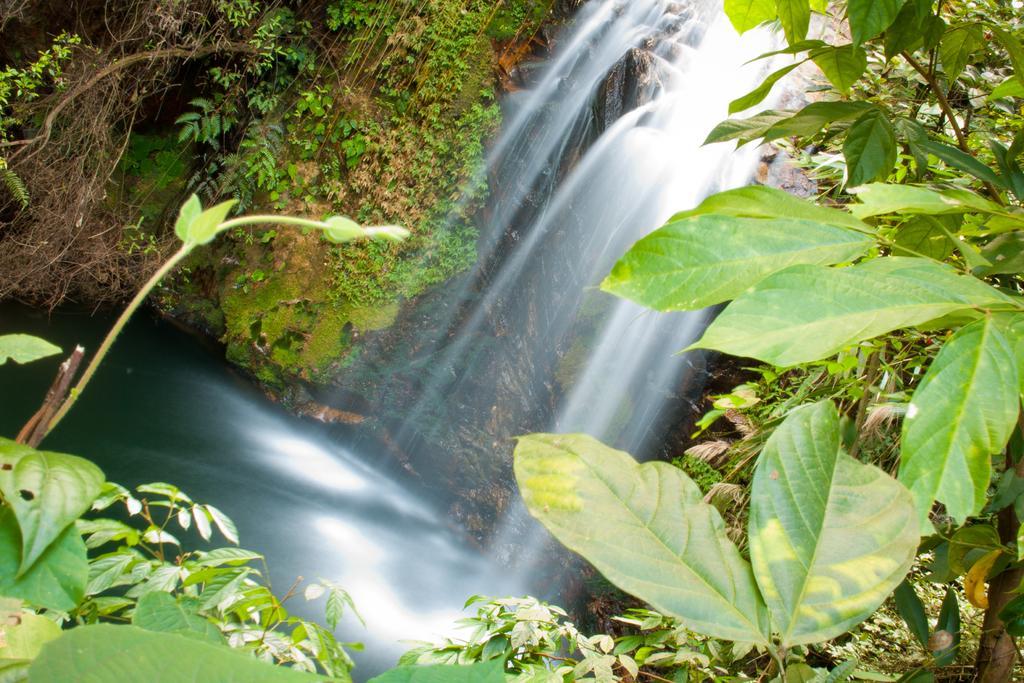In one or two sentences, can you explain what this image depicts? In this image we can see water, plants, and trees. 